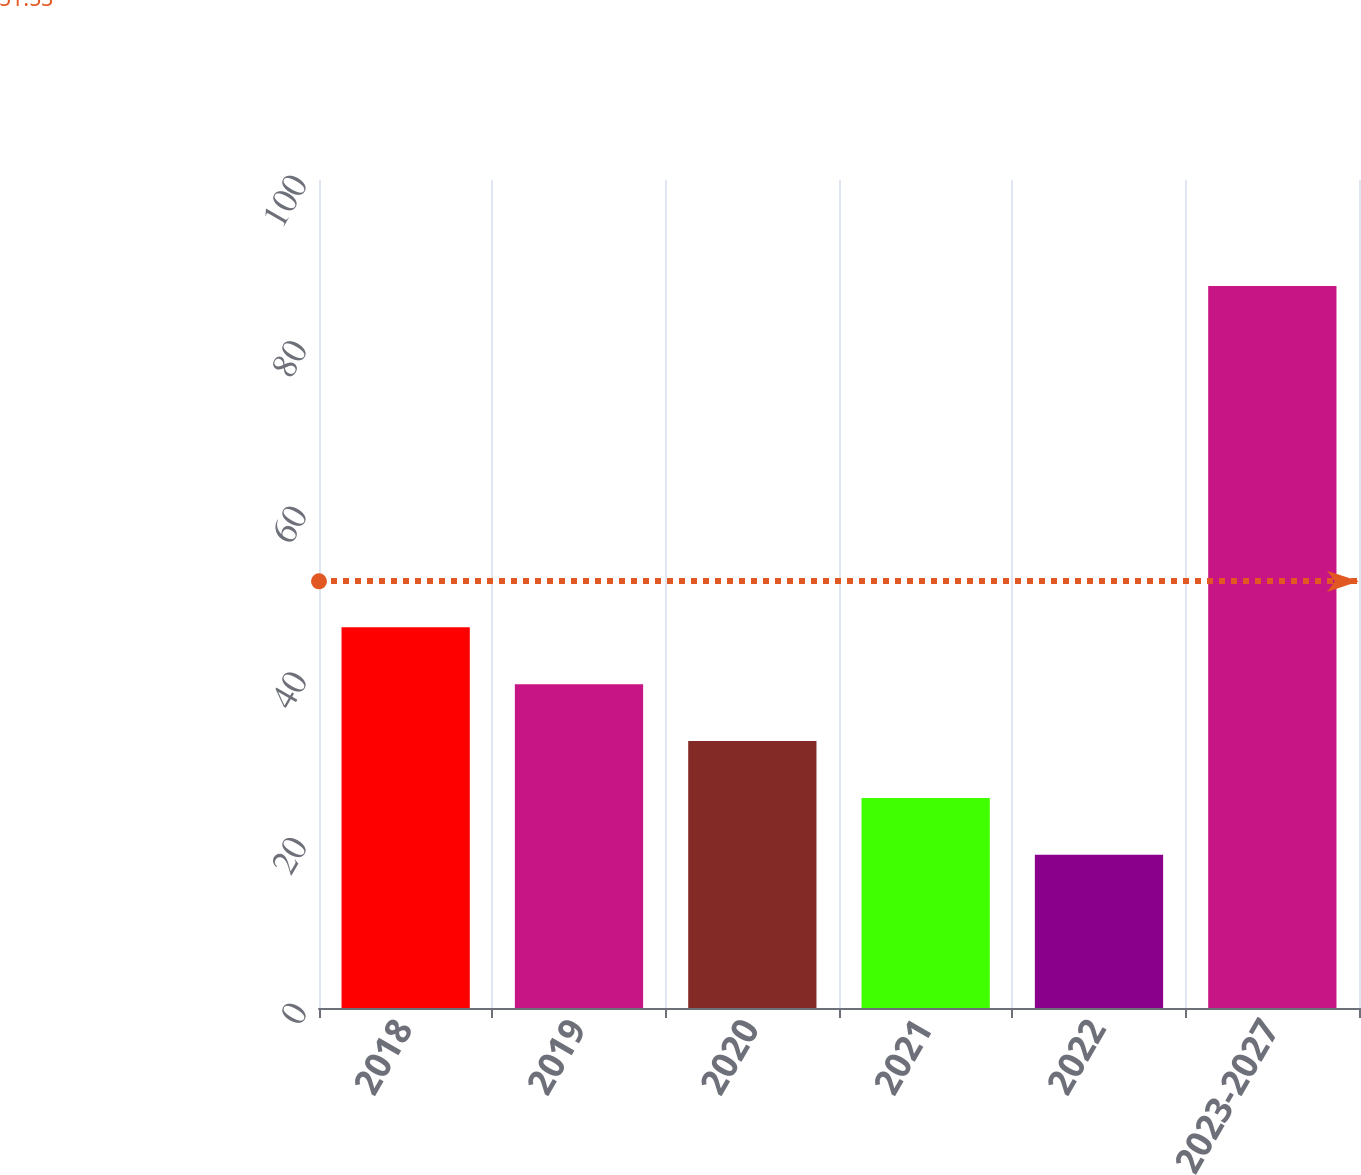Convert chart to OTSL. <chart><loc_0><loc_0><loc_500><loc_500><bar_chart><fcel>2018<fcel>2019<fcel>2020<fcel>2021<fcel>2022<fcel>2023-2027<nl><fcel>45.98<fcel>39.11<fcel>32.24<fcel>25.37<fcel>18.5<fcel>87.2<nl></chart> 